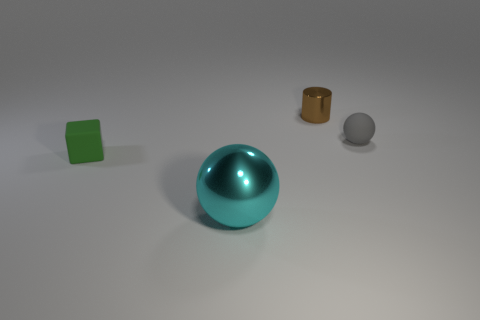Subtract all cylinders. How many objects are left? 3 Add 2 small matte cubes. How many objects exist? 6 Subtract all gray balls. How many balls are left? 1 Add 2 tiny balls. How many tiny balls are left? 3 Add 4 big purple metal cylinders. How many big purple metal cylinders exist? 4 Subtract 0 blue cylinders. How many objects are left? 4 Subtract 1 cylinders. How many cylinders are left? 0 Subtract all blue blocks. Subtract all purple cylinders. How many blocks are left? 1 Subtract all brown cubes. How many cyan balls are left? 1 Subtract all blue metal cylinders. Subtract all tiny gray balls. How many objects are left? 3 